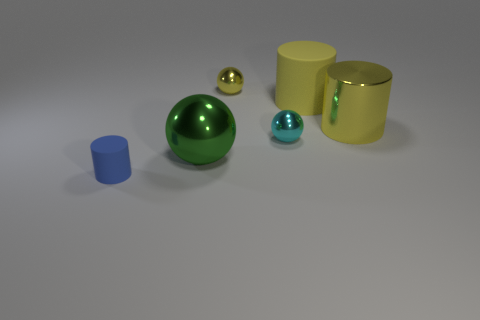Is there a big gray ball made of the same material as the big green object?
Your response must be concise. No. There is a tiny metal sphere in front of the matte thing that is to the right of the small ball behind the large matte thing; what is its color?
Give a very brief answer. Cyan. What number of green objects are either tiny matte cylinders or large shiny spheres?
Your response must be concise. 1. How many other tiny blue rubber things are the same shape as the blue object?
Ensure brevity in your answer.  0. What is the shape of the yellow object that is the same size as the yellow rubber cylinder?
Provide a succinct answer. Cylinder. There is a big green ball; are there any green spheres on the right side of it?
Offer a very short reply. No. Are there any matte things that are in front of the small blue matte cylinder that is in front of the yellow rubber thing?
Ensure brevity in your answer.  No. Is the number of small metallic spheres that are right of the yellow rubber cylinder less than the number of blue rubber cylinders behind the small cyan metal thing?
Offer a very short reply. No. Is there any other thing that has the same size as the blue rubber cylinder?
Your response must be concise. Yes. What is the shape of the blue object?
Provide a succinct answer. Cylinder. 